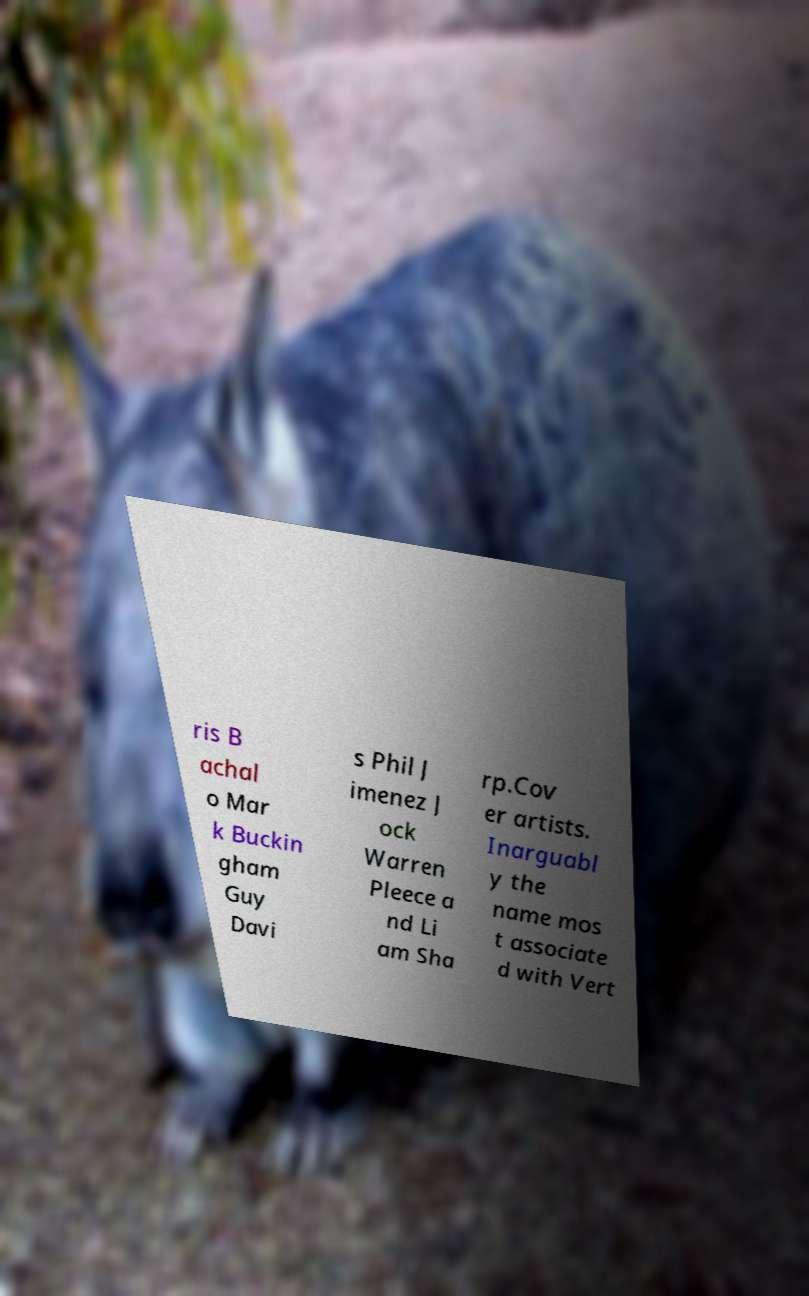Can you read and provide the text displayed in the image?This photo seems to have some interesting text. Can you extract and type it out for me? ris B achal o Mar k Buckin gham Guy Davi s Phil J imenez J ock Warren Pleece a nd Li am Sha rp.Cov er artists. Inarguabl y the name mos t associate d with Vert 